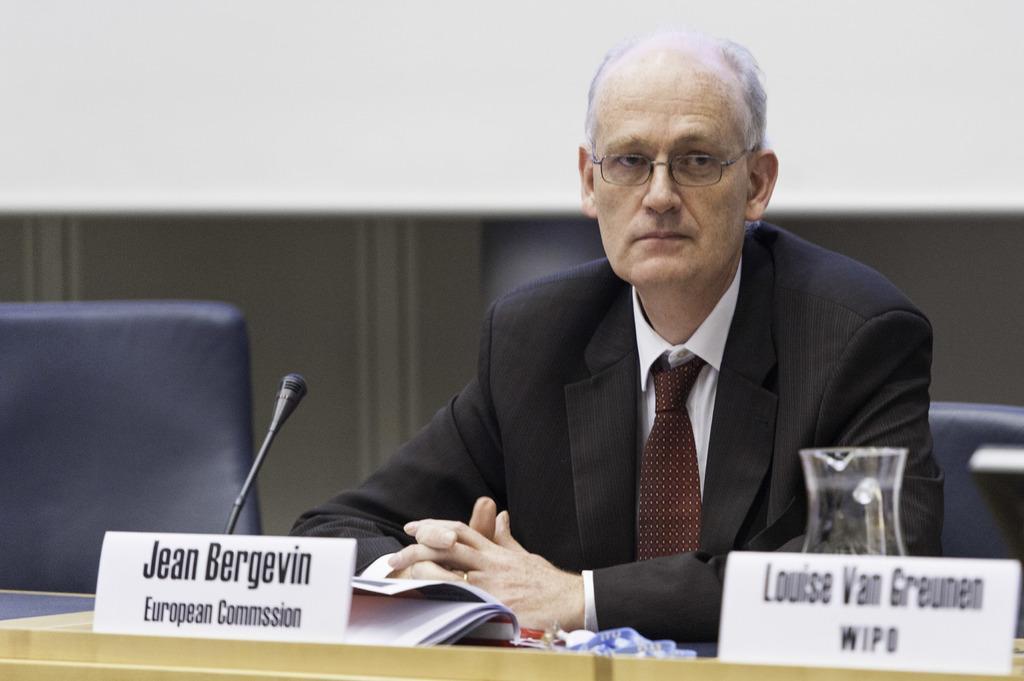How would you summarize this image in a sentence or two? In this image there is a person sitting on the chair. In front of him there is a table and on top of the table there is a jar, name boards, mike and a book. Beside him there are chairs. Behind him there is a wall. 